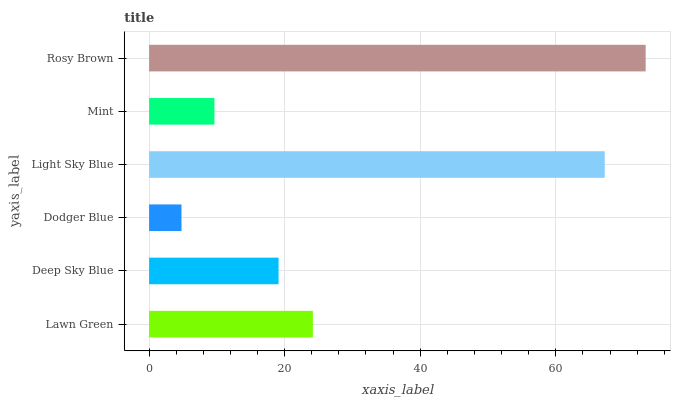Is Dodger Blue the minimum?
Answer yes or no. Yes. Is Rosy Brown the maximum?
Answer yes or no. Yes. Is Deep Sky Blue the minimum?
Answer yes or no. No. Is Deep Sky Blue the maximum?
Answer yes or no. No. Is Lawn Green greater than Deep Sky Blue?
Answer yes or no. Yes. Is Deep Sky Blue less than Lawn Green?
Answer yes or no. Yes. Is Deep Sky Blue greater than Lawn Green?
Answer yes or no. No. Is Lawn Green less than Deep Sky Blue?
Answer yes or no. No. Is Lawn Green the high median?
Answer yes or no. Yes. Is Deep Sky Blue the low median?
Answer yes or no. Yes. Is Dodger Blue the high median?
Answer yes or no. No. Is Mint the low median?
Answer yes or no. No. 